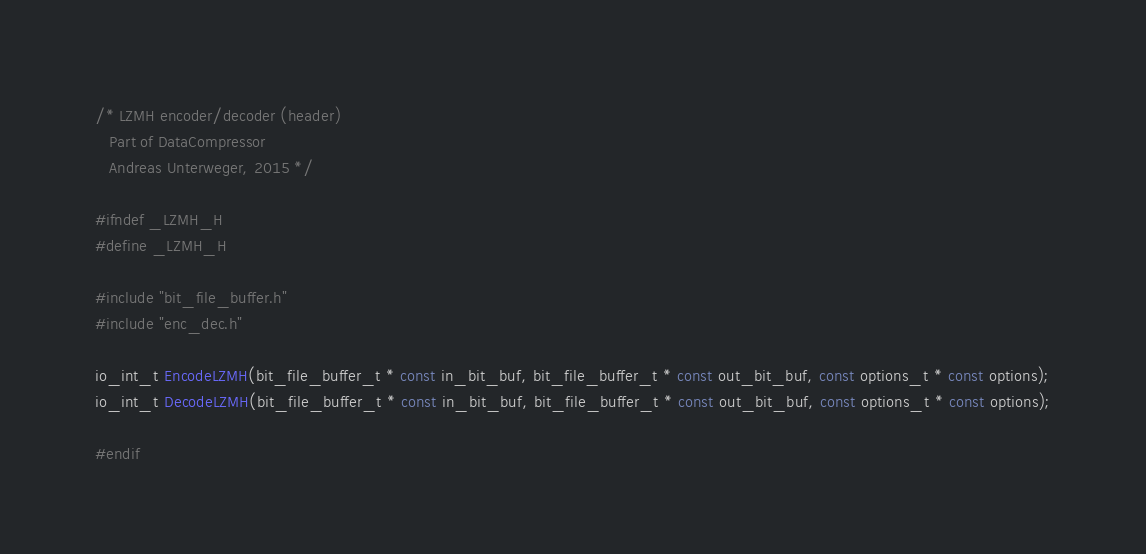Convert code to text. <code><loc_0><loc_0><loc_500><loc_500><_C_>/* LZMH encoder/decoder (header)
   Part of DataCompressor
   Andreas Unterweger, 2015 */

#ifndef _LZMH_H
#define _LZMH_H

#include "bit_file_buffer.h"
#include "enc_dec.h"

io_int_t EncodeLZMH(bit_file_buffer_t * const in_bit_buf, bit_file_buffer_t * const out_bit_buf, const options_t * const options);
io_int_t DecodeLZMH(bit_file_buffer_t * const in_bit_buf, bit_file_buffer_t * const out_bit_buf, const options_t * const options);

#endif</code> 